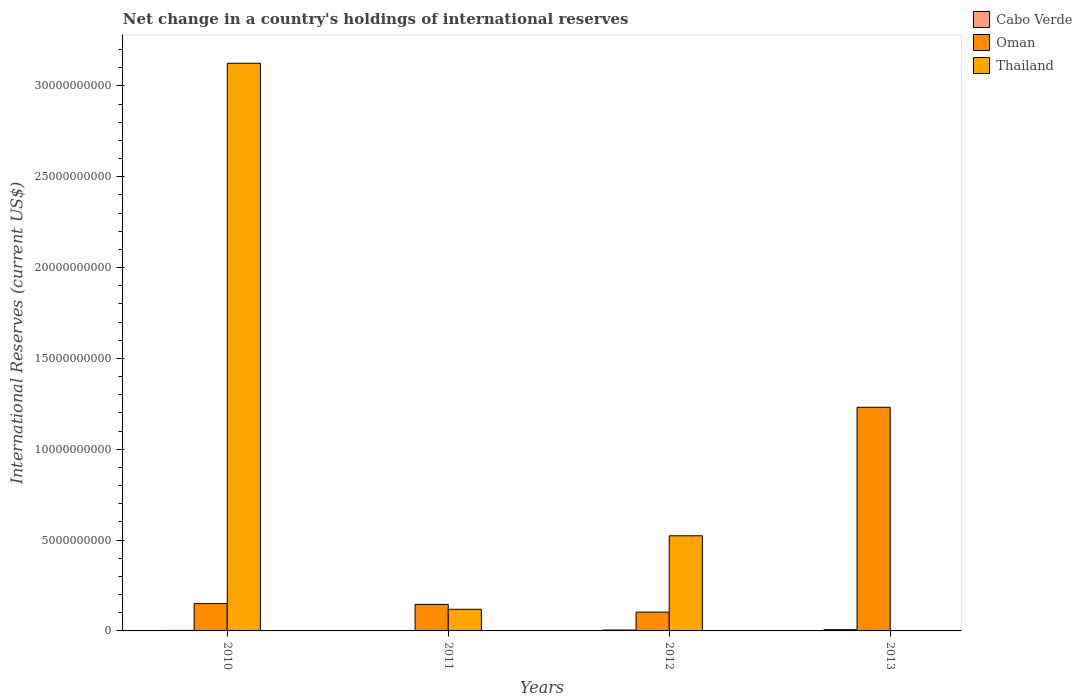Are the number of bars per tick equal to the number of legend labels?
Provide a succinct answer. No. What is the label of the 3rd group of bars from the left?
Your answer should be very brief. 2012. In how many cases, is the number of bars for a given year not equal to the number of legend labels?
Provide a short and direct response. 2. What is the international reserves in Cabo Verde in 2012?
Offer a very short reply. 4.97e+07. Across all years, what is the maximum international reserves in Cabo Verde?
Your answer should be compact. 7.03e+07. Across all years, what is the minimum international reserves in Cabo Verde?
Your answer should be compact. 0. In which year was the international reserves in Oman maximum?
Ensure brevity in your answer.  2013. What is the total international reserves in Oman in the graph?
Provide a succinct answer. 1.63e+1. What is the difference between the international reserves in Cabo Verde in 2010 and that in 2012?
Provide a succinct answer. -2.14e+07. What is the difference between the international reserves in Oman in 2010 and the international reserves in Cabo Verde in 2013?
Keep it short and to the point. 1.43e+09. What is the average international reserves in Thailand per year?
Your answer should be very brief. 9.42e+09. In the year 2010, what is the difference between the international reserves in Thailand and international reserves in Cabo Verde?
Make the answer very short. 3.12e+1. In how many years, is the international reserves in Cabo Verde greater than 26000000000 US$?
Provide a succinct answer. 0. What is the ratio of the international reserves in Thailand in 2010 to that in 2012?
Your response must be concise. 5.97. Is the international reserves in Cabo Verde in 2010 less than that in 2013?
Give a very brief answer. Yes. Is the difference between the international reserves in Thailand in 2010 and 2012 greater than the difference between the international reserves in Cabo Verde in 2010 and 2012?
Your answer should be very brief. Yes. What is the difference between the highest and the second highest international reserves in Thailand?
Your answer should be very brief. 2.60e+1. What is the difference between the highest and the lowest international reserves in Cabo Verde?
Provide a short and direct response. 7.03e+07. Is the sum of the international reserves in Oman in 2010 and 2011 greater than the maximum international reserves in Cabo Verde across all years?
Your response must be concise. Yes. Is it the case that in every year, the sum of the international reserves in Cabo Verde and international reserves in Thailand is greater than the international reserves in Oman?
Your response must be concise. No. How many bars are there?
Offer a very short reply. 10. Are all the bars in the graph horizontal?
Make the answer very short. No. How many years are there in the graph?
Provide a succinct answer. 4. What is the difference between two consecutive major ticks on the Y-axis?
Provide a short and direct response. 5.00e+09. Are the values on the major ticks of Y-axis written in scientific E-notation?
Ensure brevity in your answer.  No. Does the graph contain any zero values?
Make the answer very short. Yes. Does the graph contain grids?
Offer a terse response. No. What is the title of the graph?
Offer a terse response. Net change in a country's holdings of international reserves. What is the label or title of the Y-axis?
Offer a very short reply. International Reserves (current US$). What is the International Reserves (current US$) of Cabo Verde in 2010?
Provide a succinct answer. 2.83e+07. What is the International Reserves (current US$) of Oman in 2010?
Offer a very short reply. 1.50e+09. What is the International Reserves (current US$) of Thailand in 2010?
Provide a short and direct response. 3.12e+1. What is the International Reserves (current US$) of Cabo Verde in 2011?
Give a very brief answer. 0. What is the International Reserves (current US$) in Oman in 2011?
Offer a terse response. 1.46e+09. What is the International Reserves (current US$) in Thailand in 2011?
Make the answer very short. 1.19e+09. What is the International Reserves (current US$) of Cabo Verde in 2012?
Offer a very short reply. 4.97e+07. What is the International Reserves (current US$) of Oman in 2012?
Your answer should be compact. 1.03e+09. What is the International Reserves (current US$) in Thailand in 2012?
Your response must be concise. 5.24e+09. What is the International Reserves (current US$) in Cabo Verde in 2013?
Offer a terse response. 7.03e+07. What is the International Reserves (current US$) in Oman in 2013?
Your response must be concise. 1.23e+1. Across all years, what is the maximum International Reserves (current US$) of Cabo Verde?
Offer a terse response. 7.03e+07. Across all years, what is the maximum International Reserves (current US$) in Oman?
Offer a terse response. 1.23e+1. Across all years, what is the maximum International Reserves (current US$) of Thailand?
Ensure brevity in your answer.  3.12e+1. Across all years, what is the minimum International Reserves (current US$) of Cabo Verde?
Make the answer very short. 0. Across all years, what is the minimum International Reserves (current US$) in Oman?
Your response must be concise. 1.03e+09. What is the total International Reserves (current US$) of Cabo Verde in the graph?
Provide a succinct answer. 1.48e+08. What is the total International Reserves (current US$) of Oman in the graph?
Provide a short and direct response. 1.63e+1. What is the total International Reserves (current US$) in Thailand in the graph?
Your answer should be very brief. 3.77e+1. What is the difference between the International Reserves (current US$) of Oman in 2010 and that in 2011?
Keep it short and to the point. 4.31e+07. What is the difference between the International Reserves (current US$) in Thailand in 2010 and that in 2011?
Provide a succinct answer. 3.01e+1. What is the difference between the International Reserves (current US$) of Cabo Verde in 2010 and that in 2012?
Provide a succinct answer. -2.14e+07. What is the difference between the International Reserves (current US$) in Oman in 2010 and that in 2012?
Offer a terse response. 4.71e+08. What is the difference between the International Reserves (current US$) of Thailand in 2010 and that in 2012?
Make the answer very short. 2.60e+1. What is the difference between the International Reserves (current US$) of Cabo Verde in 2010 and that in 2013?
Provide a short and direct response. -4.20e+07. What is the difference between the International Reserves (current US$) of Oman in 2010 and that in 2013?
Offer a very short reply. -1.08e+1. What is the difference between the International Reserves (current US$) in Oman in 2011 and that in 2012?
Provide a succinct answer. 4.28e+08. What is the difference between the International Reserves (current US$) of Thailand in 2011 and that in 2012?
Offer a very short reply. -4.05e+09. What is the difference between the International Reserves (current US$) of Oman in 2011 and that in 2013?
Keep it short and to the point. -1.08e+1. What is the difference between the International Reserves (current US$) of Cabo Verde in 2012 and that in 2013?
Your response must be concise. -2.06e+07. What is the difference between the International Reserves (current US$) of Oman in 2012 and that in 2013?
Your answer should be very brief. -1.13e+1. What is the difference between the International Reserves (current US$) in Cabo Verde in 2010 and the International Reserves (current US$) in Oman in 2011?
Keep it short and to the point. -1.43e+09. What is the difference between the International Reserves (current US$) of Cabo Verde in 2010 and the International Reserves (current US$) of Thailand in 2011?
Your answer should be very brief. -1.16e+09. What is the difference between the International Reserves (current US$) of Oman in 2010 and the International Reserves (current US$) of Thailand in 2011?
Your answer should be compact. 3.14e+08. What is the difference between the International Reserves (current US$) of Cabo Verde in 2010 and the International Reserves (current US$) of Oman in 2012?
Offer a very short reply. -1.01e+09. What is the difference between the International Reserves (current US$) of Cabo Verde in 2010 and the International Reserves (current US$) of Thailand in 2012?
Keep it short and to the point. -5.21e+09. What is the difference between the International Reserves (current US$) in Oman in 2010 and the International Reserves (current US$) in Thailand in 2012?
Offer a very short reply. -3.73e+09. What is the difference between the International Reserves (current US$) in Cabo Verde in 2010 and the International Reserves (current US$) in Oman in 2013?
Your answer should be compact. -1.23e+1. What is the difference between the International Reserves (current US$) of Oman in 2011 and the International Reserves (current US$) of Thailand in 2012?
Keep it short and to the point. -3.78e+09. What is the difference between the International Reserves (current US$) in Cabo Verde in 2012 and the International Reserves (current US$) in Oman in 2013?
Your answer should be compact. -1.23e+1. What is the average International Reserves (current US$) in Cabo Verde per year?
Your response must be concise. 3.71e+07. What is the average International Reserves (current US$) in Oman per year?
Give a very brief answer. 4.08e+09. What is the average International Reserves (current US$) in Thailand per year?
Make the answer very short. 9.42e+09. In the year 2010, what is the difference between the International Reserves (current US$) of Cabo Verde and International Reserves (current US$) of Oman?
Ensure brevity in your answer.  -1.48e+09. In the year 2010, what is the difference between the International Reserves (current US$) in Cabo Verde and International Reserves (current US$) in Thailand?
Give a very brief answer. -3.12e+1. In the year 2010, what is the difference between the International Reserves (current US$) in Oman and International Reserves (current US$) in Thailand?
Make the answer very short. -2.97e+1. In the year 2011, what is the difference between the International Reserves (current US$) of Oman and International Reserves (current US$) of Thailand?
Make the answer very short. 2.70e+08. In the year 2012, what is the difference between the International Reserves (current US$) in Cabo Verde and International Reserves (current US$) in Oman?
Give a very brief answer. -9.84e+08. In the year 2012, what is the difference between the International Reserves (current US$) of Cabo Verde and International Reserves (current US$) of Thailand?
Your answer should be very brief. -5.19e+09. In the year 2012, what is the difference between the International Reserves (current US$) in Oman and International Reserves (current US$) in Thailand?
Your answer should be very brief. -4.20e+09. In the year 2013, what is the difference between the International Reserves (current US$) in Cabo Verde and International Reserves (current US$) in Oman?
Your answer should be very brief. -1.22e+1. What is the ratio of the International Reserves (current US$) of Oman in 2010 to that in 2011?
Your response must be concise. 1.03. What is the ratio of the International Reserves (current US$) in Thailand in 2010 to that in 2011?
Offer a very short reply. 26.24. What is the ratio of the International Reserves (current US$) of Cabo Verde in 2010 to that in 2012?
Give a very brief answer. 0.57. What is the ratio of the International Reserves (current US$) of Oman in 2010 to that in 2012?
Your response must be concise. 1.46. What is the ratio of the International Reserves (current US$) in Thailand in 2010 to that in 2012?
Keep it short and to the point. 5.97. What is the ratio of the International Reserves (current US$) in Cabo Verde in 2010 to that in 2013?
Offer a very short reply. 0.4. What is the ratio of the International Reserves (current US$) in Oman in 2010 to that in 2013?
Provide a succinct answer. 0.12. What is the ratio of the International Reserves (current US$) in Oman in 2011 to that in 2012?
Offer a very short reply. 1.41. What is the ratio of the International Reserves (current US$) in Thailand in 2011 to that in 2012?
Give a very brief answer. 0.23. What is the ratio of the International Reserves (current US$) of Oman in 2011 to that in 2013?
Your response must be concise. 0.12. What is the ratio of the International Reserves (current US$) in Cabo Verde in 2012 to that in 2013?
Provide a short and direct response. 0.71. What is the ratio of the International Reserves (current US$) in Oman in 2012 to that in 2013?
Offer a very short reply. 0.08. What is the difference between the highest and the second highest International Reserves (current US$) of Cabo Verde?
Keep it short and to the point. 2.06e+07. What is the difference between the highest and the second highest International Reserves (current US$) of Oman?
Make the answer very short. 1.08e+1. What is the difference between the highest and the second highest International Reserves (current US$) in Thailand?
Provide a succinct answer. 2.60e+1. What is the difference between the highest and the lowest International Reserves (current US$) of Cabo Verde?
Provide a succinct answer. 7.03e+07. What is the difference between the highest and the lowest International Reserves (current US$) in Oman?
Keep it short and to the point. 1.13e+1. What is the difference between the highest and the lowest International Reserves (current US$) of Thailand?
Your answer should be compact. 3.12e+1. 